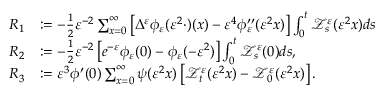<formula> <loc_0><loc_0><loc_500><loc_500>\begin{array} { r l } { R _ { 1 } } & { \colon = - \frac { 1 } { 2 } \varepsilon ^ { - 2 } \sum _ { x = 0 } ^ { \infty } \left [ \Delta ^ { \varepsilon } \phi _ { \varepsilon } ( \varepsilon ^ { 2 } \cdot ) ( x ) - \varepsilon ^ { 4 } \phi _ { \varepsilon } ^ { \prime \prime } ( \varepsilon ^ { 2 } x ) \right ] \int _ { 0 } ^ { t } \ m a t h s c r { Z } _ { s } ^ { \varepsilon } ( \varepsilon ^ { 2 } x ) d s } \\ { R _ { 2 } } & { \colon = - \frac { 1 } { 2 } \varepsilon ^ { - 2 } \left [ e ^ { - \varepsilon } \phi _ { \varepsilon } ( 0 ) - \phi _ { \varepsilon } ( - \varepsilon ^ { 2 } ) \right ] \int _ { 0 } ^ { t } \ m a t h s c r { Z } _ { s } ^ { \varepsilon } ( 0 ) d s , } \\ { R _ { 3 } } & { \colon = \varepsilon ^ { 3 } \phi ^ { \prime } ( 0 ) \sum _ { x = 0 } ^ { \infty } \psi ( \varepsilon ^ { 2 } x ) \left [ \ m a t h s c r { Z } _ { t } ^ { \varepsilon } ( \varepsilon ^ { 2 } x ) - \ m a t h s c r { Z } _ { 0 } ^ { \varepsilon } ( \varepsilon ^ { 2 } x ) \right ] . } \end{array}</formula> 